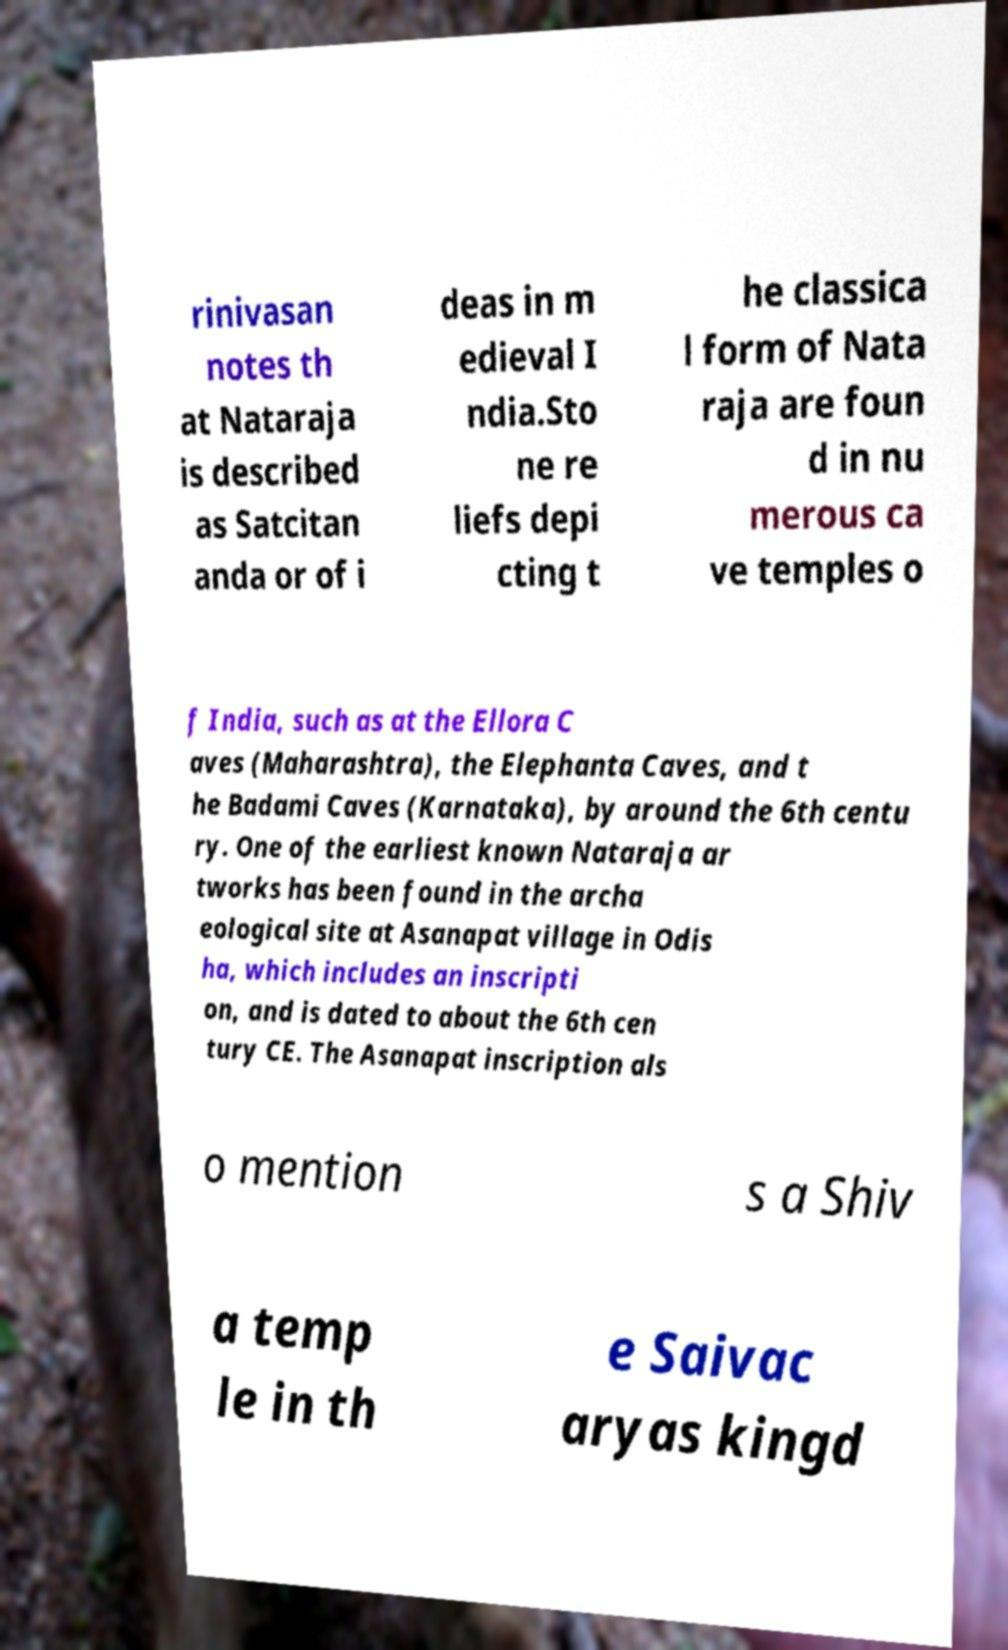Please read and relay the text visible in this image. What does it say? rinivasan notes th at Nataraja is described as Satcitan anda or of i deas in m edieval I ndia.Sto ne re liefs depi cting t he classica l form of Nata raja are foun d in nu merous ca ve temples o f India, such as at the Ellora C aves (Maharashtra), the Elephanta Caves, and t he Badami Caves (Karnataka), by around the 6th centu ry. One of the earliest known Nataraja ar tworks has been found in the archa eological site at Asanapat village in Odis ha, which includes an inscripti on, and is dated to about the 6th cen tury CE. The Asanapat inscription als o mention s a Shiv a temp le in th e Saivac aryas kingd 